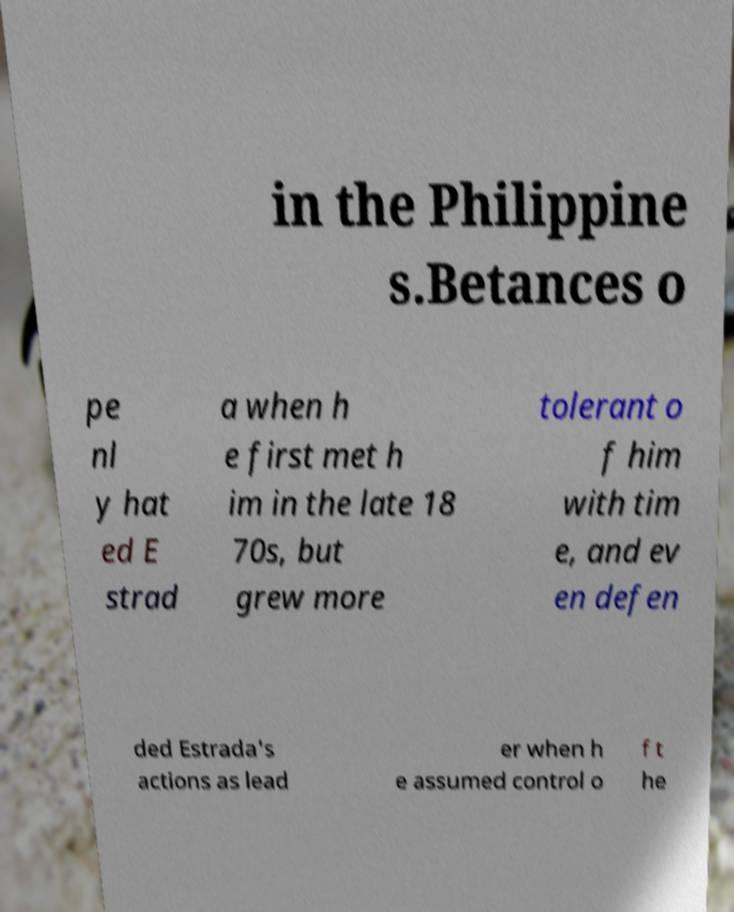There's text embedded in this image that I need extracted. Can you transcribe it verbatim? in the Philippine s.Betances o pe nl y hat ed E strad a when h e first met h im in the late 18 70s, but grew more tolerant o f him with tim e, and ev en defen ded Estrada's actions as lead er when h e assumed control o f t he 